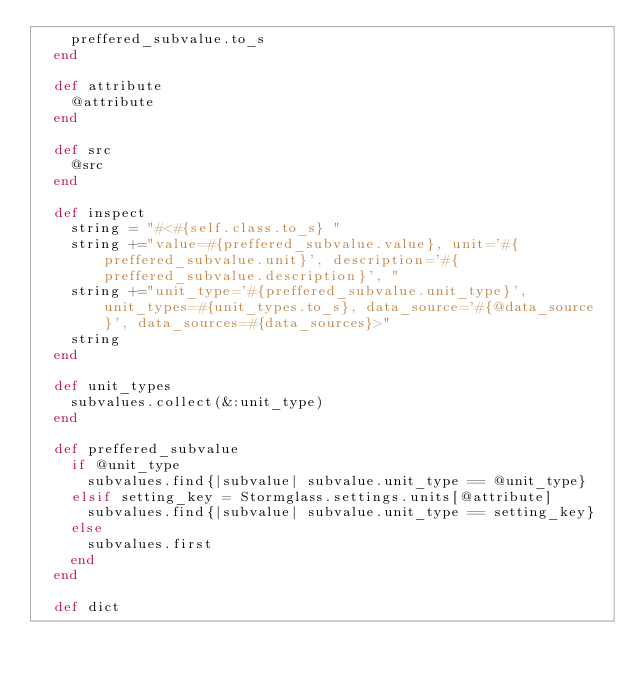Convert code to text. <code><loc_0><loc_0><loc_500><loc_500><_Ruby_>    preffered_subvalue.to_s
  end

  def attribute
    @attribute
  end

  def src
    @src
  end

  def inspect
    string = "#<#{self.class.to_s} "
    string +="value=#{preffered_subvalue.value}, unit='#{preffered_subvalue.unit}', description='#{preffered_subvalue.description}', "
    string +="unit_type='#{preffered_subvalue.unit_type}', unit_types=#{unit_types.to_s}, data_source='#{@data_source}', data_sources=#{data_sources}>"
    string
  end

  def unit_types
    subvalues.collect(&:unit_type)
  end

  def preffered_subvalue
    if @unit_type
      subvalues.find{|subvalue| subvalue.unit_type == @unit_type}
    elsif setting_key = Stormglass.settings.units[@attribute]
      subvalues.find{|subvalue| subvalue.unit_type == setting_key}
    else
      subvalues.first
    end
  end

  def dict</code> 